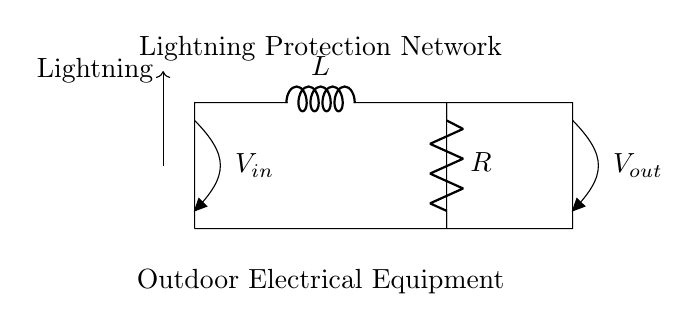What is the main purpose of this circuit? The main purpose of this circuit is to protect outdoor electrical equipment from lightning strikes by using a resistor and an inductor to limit the voltage and manage the transient current.
Answer: Lightning protection What components are used in this circuit? The circuit consists of a resistor and an inductor, which are used to control and protect against voltage surges.
Answer: Resistor and inductor What is the input voltage source labeled as in the circuit? The input voltage source is labeled as V-in, indicating the voltage applied at the start of the circuit.
Answer: V-in How does the inclusion of the inductor affect the circuit? The inductor resists changes in current and helps to smooth out transients, reducing the effect of sudden surges from lightning strikes.
Answer: It smooths out transients What is the voltage across the output labeled as? The voltage across the output is labeled as V-out, which gives the potential difference at the end of the circuit.
Answer: V-out How does the resistor contribute to the circuit's functioning? The resistor limits the current flowing through the circuit, helping to prevent damage to the connected equipment from high surges.
Answer: It limits the current What is the effect of a lightning strike on this circuit? A lightning strike generates a sudden surge of electricity, which the resistor and inductor together help to mitigate, protecting the outdoor equipment from damage.
Answer: Mitigated surge 